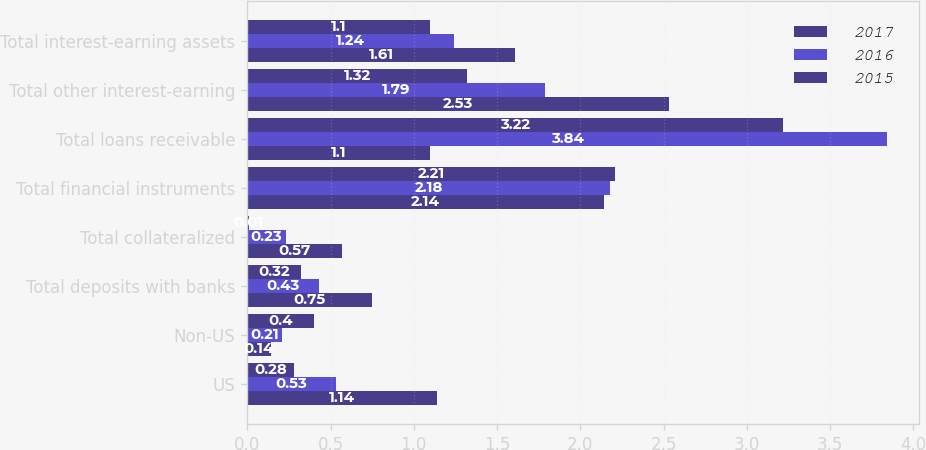Convert chart. <chart><loc_0><loc_0><loc_500><loc_500><stacked_bar_chart><ecel><fcel>US<fcel>Non-US<fcel>Total deposits with banks<fcel>Total collateralized<fcel>Total financial instruments<fcel>Total loans receivable<fcel>Total other interest-earning<fcel>Total interest-earning assets<nl><fcel>2017<fcel>1.14<fcel>0.14<fcel>0.75<fcel>0.57<fcel>2.14<fcel>1.1<fcel>2.53<fcel>1.61<nl><fcel>2016<fcel>0.53<fcel>0.21<fcel>0.43<fcel>0.23<fcel>2.18<fcel>3.84<fcel>1.79<fcel>1.24<nl><fcel>2015<fcel>0.28<fcel>0.4<fcel>0.32<fcel>0.01<fcel>2.21<fcel>3.22<fcel>1.32<fcel>1.1<nl></chart> 